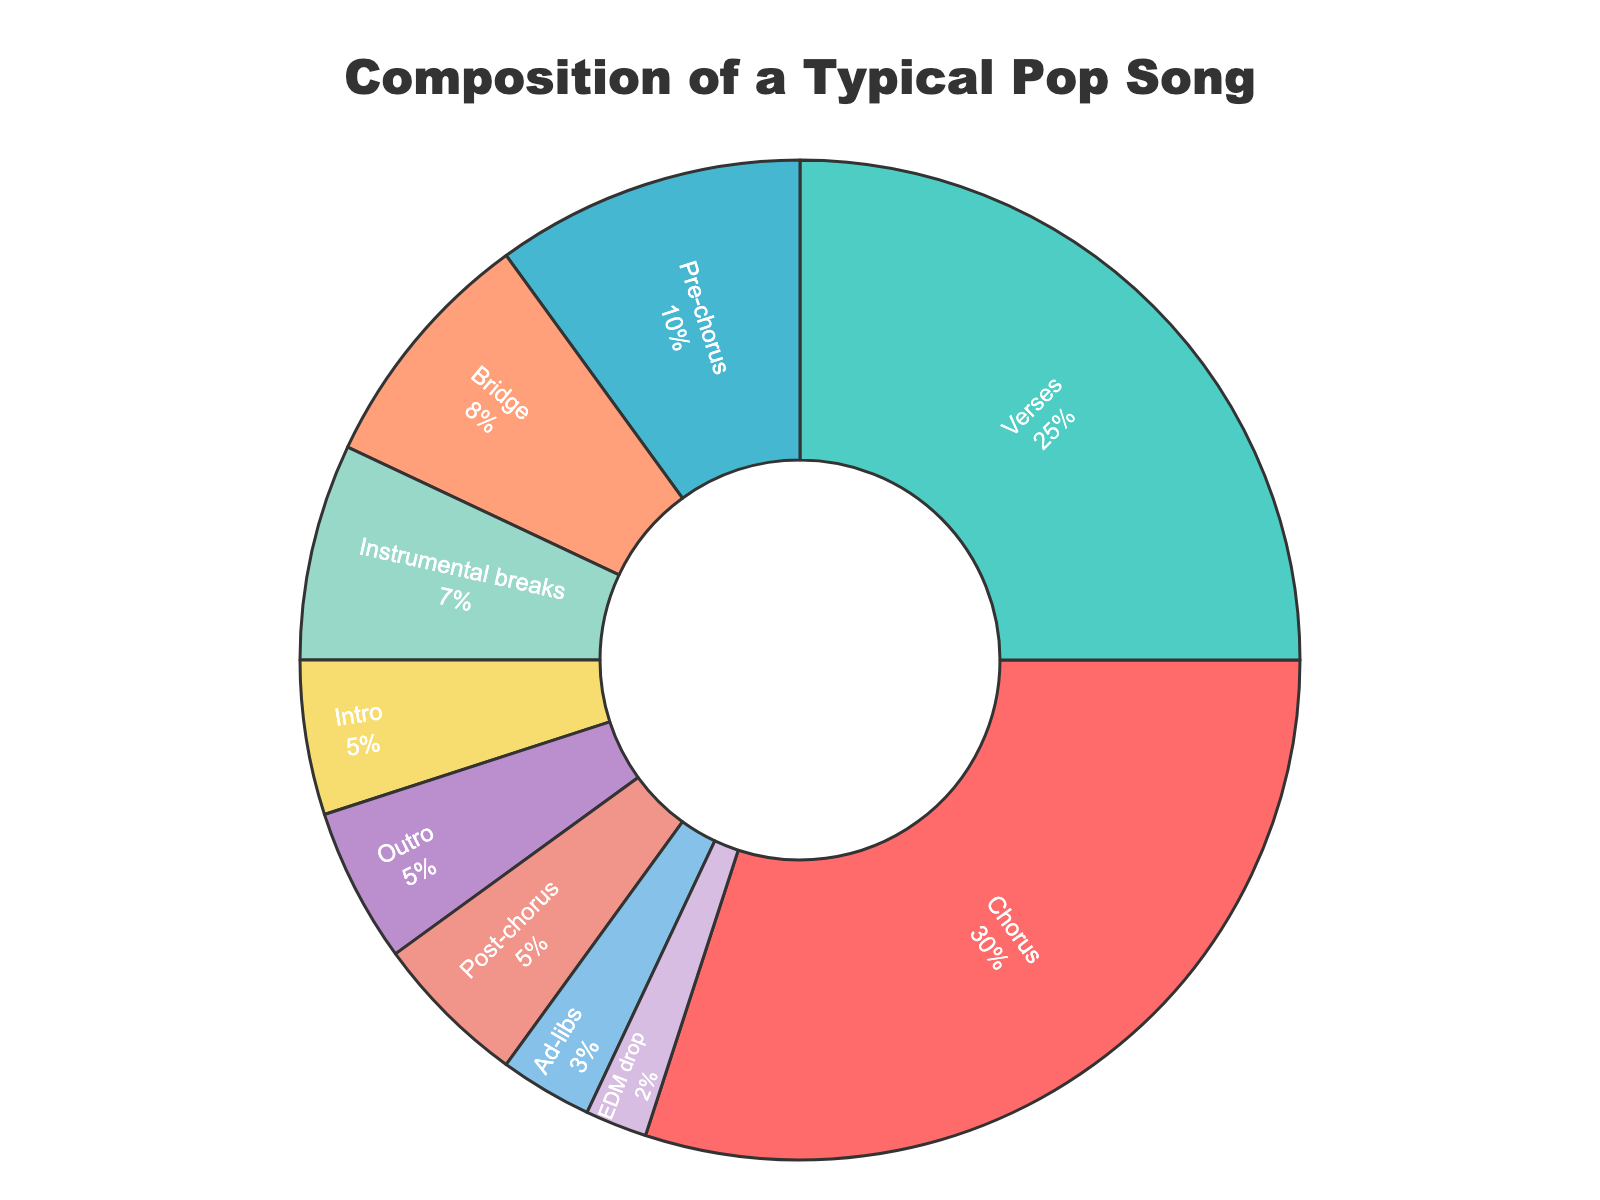What section takes up the largest percentage of a typical pop song? The section with the largest percentage is the chorus, as represented visually by the largest segment of the pie chart.
Answer: Chorus How much of the song is not allocated to either the chorus or the verses? The chorus and verses take up 55% combined (30% chorus + 25% verses), leaving 45% for the other sections.
Answer: 45% Is the percentage dedicated to the outro greater than the percentage dedicated to the intro? The intro and outro each take up 5% of the song, so they are equal.
Answer: No By how much is the percentage of the chorus greater than the verses in a typical pop song? The chorus is 30% and the verses are 25%, so the difference is 5%.
Answer: 5% What is the combined percentage for the sections: bridge, ad-libs, and EDM drop? Adding the bridge (8%), ad-libs (3%), and EDM drop (2%) results in a total of 13%.
Answer: 13% How does the percentage of the instrumental breaks compare to that of the bridge? The instrumental breaks take up 7%, while the bridge takes up 8%, so the bridge is 1% more.
Answer: Bridge 1% more What is the smallest section in terms of percentage, and what is its percentage? The smallest section is the EDM drop at 2%.
Answer: EDM drop, 2% What's the total percentage of all the sections starting with the letter "P"? Adding pre-chorus (10%) and post-chorus (5%), we get a total of 15%.
Answer: 15% Which sections together form one-half of the entire song? The sections forming exactly 50% are chorus (30%) and verses (25%); combined, they form 55%, but no other combination forms exactly 50%.
Answer: None 